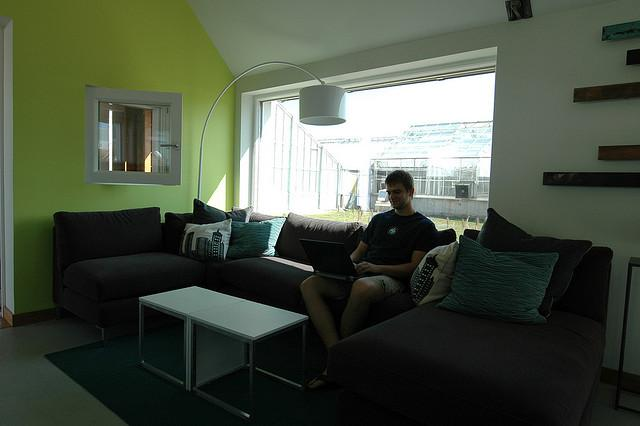What are his fingers touching? Please explain your reasoning. keyboard. He has a lap top in front of him that he is working on. 